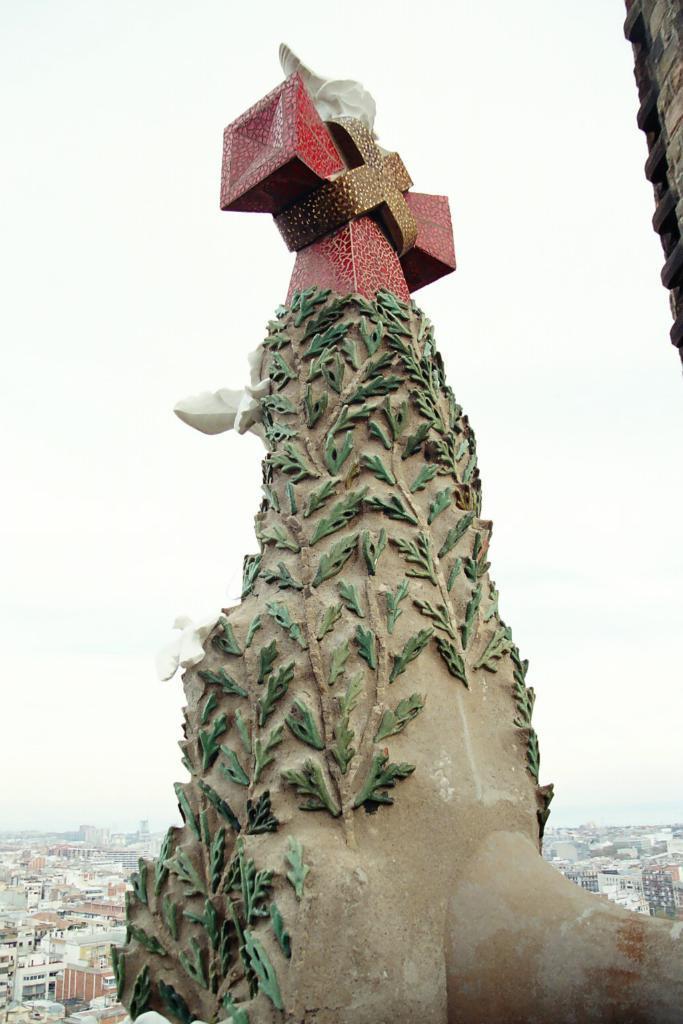Can you describe this image briefly? In this image there is a sculpture, in the background there are buildings and the sky. 